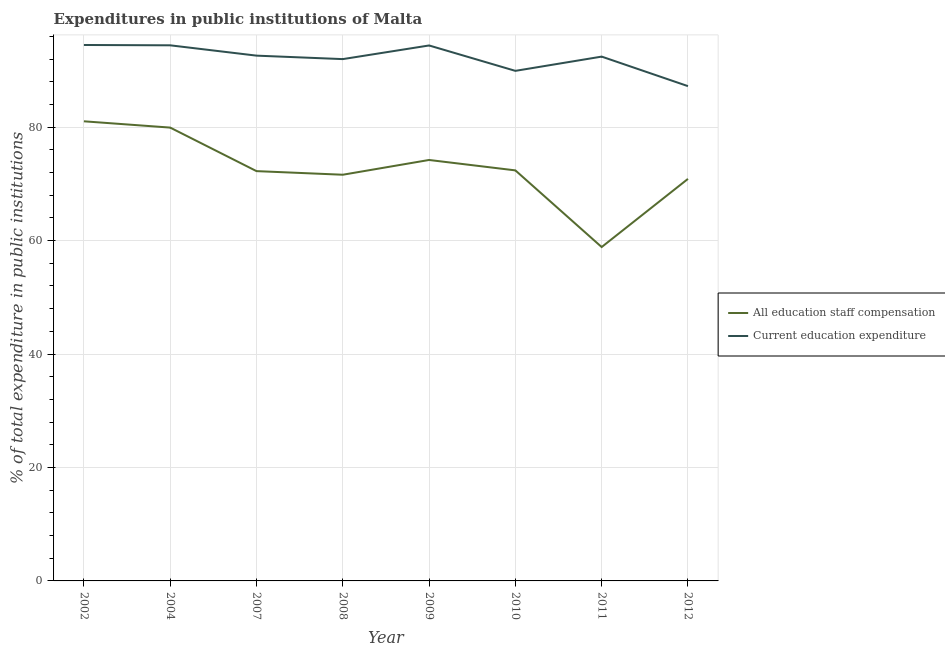How many different coloured lines are there?
Provide a short and direct response. 2. What is the expenditure in staff compensation in 2007?
Offer a terse response. 72.24. Across all years, what is the maximum expenditure in staff compensation?
Your answer should be compact. 81.02. Across all years, what is the minimum expenditure in staff compensation?
Make the answer very short. 58.86. In which year was the expenditure in staff compensation minimum?
Offer a very short reply. 2011. What is the total expenditure in education in the graph?
Give a very brief answer. 737.44. What is the difference between the expenditure in staff compensation in 2010 and that in 2011?
Provide a succinct answer. 13.51. What is the difference between the expenditure in staff compensation in 2011 and the expenditure in education in 2009?
Offer a terse response. -35.53. What is the average expenditure in education per year?
Offer a very short reply. 92.18. In the year 2004, what is the difference between the expenditure in staff compensation and expenditure in education?
Keep it short and to the point. -14.51. In how many years, is the expenditure in staff compensation greater than 16 %?
Provide a succinct answer. 8. What is the ratio of the expenditure in education in 2002 to that in 2007?
Make the answer very short. 1.02. What is the difference between the highest and the second highest expenditure in education?
Make the answer very short. 0.06. What is the difference between the highest and the lowest expenditure in education?
Your answer should be very brief. 7.25. How many lines are there?
Give a very brief answer. 2. How many years are there in the graph?
Your answer should be compact. 8. How many legend labels are there?
Provide a short and direct response. 2. How are the legend labels stacked?
Ensure brevity in your answer.  Vertical. What is the title of the graph?
Give a very brief answer. Expenditures in public institutions of Malta. Does "Public credit registry" appear as one of the legend labels in the graph?
Ensure brevity in your answer.  No. What is the label or title of the X-axis?
Give a very brief answer. Year. What is the label or title of the Y-axis?
Offer a terse response. % of total expenditure in public institutions. What is the % of total expenditure in public institutions of All education staff compensation in 2002?
Offer a very short reply. 81.02. What is the % of total expenditure in public institutions in Current education expenditure in 2002?
Your answer should be very brief. 94.48. What is the % of total expenditure in public institutions of All education staff compensation in 2004?
Keep it short and to the point. 79.91. What is the % of total expenditure in public institutions of Current education expenditure in 2004?
Give a very brief answer. 94.42. What is the % of total expenditure in public institutions in All education staff compensation in 2007?
Provide a succinct answer. 72.24. What is the % of total expenditure in public institutions in Current education expenditure in 2007?
Your answer should be very brief. 92.6. What is the % of total expenditure in public institutions in All education staff compensation in 2008?
Ensure brevity in your answer.  71.6. What is the % of total expenditure in public institutions of Current education expenditure in 2008?
Ensure brevity in your answer.  91.99. What is the % of total expenditure in public institutions of All education staff compensation in 2009?
Make the answer very short. 74.21. What is the % of total expenditure in public institutions of Current education expenditure in 2009?
Provide a succinct answer. 94.39. What is the % of total expenditure in public institutions of All education staff compensation in 2010?
Make the answer very short. 72.37. What is the % of total expenditure in public institutions of Current education expenditure in 2010?
Your response must be concise. 89.92. What is the % of total expenditure in public institutions in All education staff compensation in 2011?
Your answer should be very brief. 58.86. What is the % of total expenditure in public institutions in Current education expenditure in 2011?
Make the answer very short. 92.43. What is the % of total expenditure in public institutions of All education staff compensation in 2012?
Ensure brevity in your answer.  70.87. What is the % of total expenditure in public institutions of Current education expenditure in 2012?
Provide a succinct answer. 87.22. Across all years, what is the maximum % of total expenditure in public institutions in All education staff compensation?
Ensure brevity in your answer.  81.02. Across all years, what is the maximum % of total expenditure in public institutions in Current education expenditure?
Make the answer very short. 94.48. Across all years, what is the minimum % of total expenditure in public institutions of All education staff compensation?
Give a very brief answer. 58.86. Across all years, what is the minimum % of total expenditure in public institutions of Current education expenditure?
Give a very brief answer. 87.22. What is the total % of total expenditure in public institutions in All education staff compensation in the graph?
Provide a short and direct response. 581.08. What is the total % of total expenditure in public institutions of Current education expenditure in the graph?
Your answer should be very brief. 737.44. What is the difference between the % of total expenditure in public institutions of All education staff compensation in 2002 and that in 2004?
Offer a very short reply. 1.11. What is the difference between the % of total expenditure in public institutions of Current education expenditure in 2002 and that in 2004?
Provide a succinct answer. 0.06. What is the difference between the % of total expenditure in public institutions in All education staff compensation in 2002 and that in 2007?
Keep it short and to the point. 8.78. What is the difference between the % of total expenditure in public institutions in Current education expenditure in 2002 and that in 2007?
Keep it short and to the point. 1.88. What is the difference between the % of total expenditure in public institutions of All education staff compensation in 2002 and that in 2008?
Provide a short and direct response. 9.42. What is the difference between the % of total expenditure in public institutions in Current education expenditure in 2002 and that in 2008?
Your response must be concise. 2.49. What is the difference between the % of total expenditure in public institutions of All education staff compensation in 2002 and that in 2009?
Make the answer very short. 6.82. What is the difference between the % of total expenditure in public institutions in Current education expenditure in 2002 and that in 2009?
Provide a short and direct response. 0.09. What is the difference between the % of total expenditure in public institutions of All education staff compensation in 2002 and that in 2010?
Your response must be concise. 8.65. What is the difference between the % of total expenditure in public institutions of Current education expenditure in 2002 and that in 2010?
Keep it short and to the point. 4.56. What is the difference between the % of total expenditure in public institutions of All education staff compensation in 2002 and that in 2011?
Give a very brief answer. 22.17. What is the difference between the % of total expenditure in public institutions of Current education expenditure in 2002 and that in 2011?
Your answer should be compact. 2.05. What is the difference between the % of total expenditure in public institutions in All education staff compensation in 2002 and that in 2012?
Make the answer very short. 10.15. What is the difference between the % of total expenditure in public institutions in Current education expenditure in 2002 and that in 2012?
Make the answer very short. 7.25. What is the difference between the % of total expenditure in public institutions of All education staff compensation in 2004 and that in 2007?
Your response must be concise. 7.67. What is the difference between the % of total expenditure in public institutions in Current education expenditure in 2004 and that in 2007?
Provide a succinct answer. 1.82. What is the difference between the % of total expenditure in public institutions of All education staff compensation in 2004 and that in 2008?
Give a very brief answer. 8.31. What is the difference between the % of total expenditure in public institutions of Current education expenditure in 2004 and that in 2008?
Keep it short and to the point. 2.43. What is the difference between the % of total expenditure in public institutions of All education staff compensation in 2004 and that in 2009?
Your answer should be very brief. 5.71. What is the difference between the % of total expenditure in public institutions of Current education expenditure in 2004 and that in 2009?
Offer a very short reply. 0.03. What is the difference between the % of total expenditure in public institutions of All education staff compensation in 2004 and that in 2010?
Your response must be concise. 7.54. What is the difference between the % of total expenditure in public institutions in Current education expenditure in 2004 and that in 2010?
Keep it short and to the point. 4.5. What is the difference between the % of total expenditure in public institutions in All education staff compensation in 2004 and that in 2011?
Give a very brief answer. 21.06. What is the difference between the % of total expenditure in public institutions of Current education expenditure in 2004 and that in 2011?
Your answer should be very brief. 1.99. What is the difference between the % of total expenditure in public institutions of All education staff compensation in 2004 and that in 2012?
Offer a very short reply. 9.04. What is the difference between the % of total expenditure in public institutions in Current education expenditure in 2004 and that in 2012?
Offer a very short reply. 7.19. What is the difference between the % of total expenditure in public institutions of All education staff compensation in 2007 and that in 2008?
Offer a very short reply. 0.64. What is the difference between the % of total expenditure in public institutions of Current education expenditure in 2007 and that in 2008?
Keep it short and to the point. 0.61. What is the difference between the % of total expenditure in public institutions in All education staff compensation in 2007 and that in 2009?
Your response must be concise. -1.97. What is the difference between the % of total expenditure in public institutions in Current education expenditure in 2007 and that in 2009?
Make the answer very short. -1.79. What is the difference between the % of total expenditure in public institutions of All education staff compensation in 2007 and that in 2010?
Your response must be concise. -0.13. What is the difference between the % of total expenditure in public institutions in Current education expenditure in 2007 and that in 2010?
Offer a very short reply. 2.68. What is the difference between the % of total expenditure in public institutions in All education staff compensation in 2007 and that in 2011?
Offer a terse response. 13.38. What is the difference between the % of total expenditure in public institutions of Current education expenditure in 2007 and that in 2011?
Keep it short and to the point. 0.17. What is the difference between the % of total expenditure in public institutions in All education staff compensation in 2007 and that in 2012?
Your answer should be compact. 1.37. What is the difference between the % of total expenditure in public institutions of Current education expenditure in 2007 and that in 2012?
Offer a very short reply. 5.38. What is the difference between the % of total expenditure in public institutions in All education staff compensation in 2008 and that in 2009?
Keep it short and to the point. -2.6. What is the difference between the % of total expenditure in public institutions in Current education expenditure in 2008 and that in 2009?
Provide a short and direct response. -2.41. What is the difference between the % of total expenditure in public institutions in All education staff compensation in 2008 and that in 2010?
Make the answer very short. -0.77. What is the difference between the % of total expenditure in public institutions of Current education expenditure in 2008 and that in 2010?
Give a very brief answer. 2.07. What is the difference between the % of total expenditure in public institutions in All education staff compensation in 2008 and that in 2011?
Give a very brief answer. 12.75. What is the difference between the % of total expenditure in public institutions of Current education expenditure in 2008 and that in 2011?
Offer a very short reply. -0.44. What is the difference between the % of total expenditure in public institutions of All education staff compensation in 2008 and that in 2012?
Offer a very short reply. 0.73. What is the difference between the % of total expenditure in public institutions of Current education expenditure in 2008 and that in 2012?
Ensure brevity in your answer.  4.76. What is the difference between the % of total expenditure in public institutions in All education staff compensation in 2009 and that in 2010?
Keep it short and to the point. 1.83. What is the difference between the % of total expenditure in public institutions of Current education expenditure in 2009 and that in 2010?
Your answer should be very brief. 4.48. What is the difference between the % of total expenditure in public institutions of All education staff compensation in 2009 and that in 2011?
Offer a very short reply. 15.35. What is the difference between the % of total expenditure in public institutions in Current education expenditure in 2009 and that in 2011?
Your response must be concise. 1.96. What is the difference between the % of total expenditure in public institutions of All education staff compensation in 2009 and that in 2012?
Your response must be concise. 3.33. What is the difference between the % of total expenditure in public institutions in Current education expenditure in 2009 and that in 2012?
Offer a terse response. 7.17. What is the difference between the % of total expenditure in public institutions of All education staff compensation in 2010 and that in 2011?
Give a very brief answer. 13.51. What is the difference between the % of total expenditure in public institutions in Current education expenditure in 2010 and that in 2011?
Your response must be concise. -2.51. What is the difference between the % of total expenditure in public institutions in All education staff compensation in 2010 and that in 2012?
Offer a very short reply. 1.5. What is the difference between the % of total expenditure in public institutions in Current education expenditure in 2010 and that in 2012?
Offer a terse response. 2.69. What is the difference between the % of total expenditure in public institutions of All education staff compensation in 2011 and that in 2012?
Provide a succinct answer. -12.02. What is the difference between the % of total expenditure in public institutions of Current education expenditure in 2011 and that in 2012?
Your response must be concise. 5.2. What is the difference between the % of total expenditure in public institutions of All education staff compensation in 2002 and the % of total expenditure in public institutions of Current education expenditure in 2004?
Provide a succinct answer. -13.4. What is the difference between the % of total expenditure in public institutions in All education staff compensation in 2002 and the % of total expenditure in public institutions in Current education expenditure in 2007?
Provide a succinct answer. -11.58. What is the difference between the % of total expenditure in public institutions of All education staff compensation in 2002 and the % of total expenditure in public institutions of Current education expenditure in 2008?
Ensure brevity in your answer.  -10.96. What is the difference between the % of total expenditure in public institutions of All education staff compensation in 2002 and the % of total expenditure in public institutions of Current education expenditure in 2009?
Your answer should be very brief. -13.37. What is the difference between the % of total expenditure in public institutions of All education staff compensation in 2002 and the % of total expenditure in public institutions of Current education expenditure in 2010?
Give a very brief answer. -8.89. What is the difference between the % of total expenditure in public institutions of All education staff compensation in 2002 and the % of total expenditure in public institutions of Current education expenditure in 2011?
Make the answer very short. -11.41. What is the difference between the % of total expenditure in public institutions in All education staff compensation in 2002 and the % of total expenditure in public institutions in Current education expenditure in 2012?
Your answer should be very brief. -6.2. What is the difference between the % of total expenditure in public institutions of All education staff compensation in 2004 and the % of total expenditure in public institutions of Current education expenditure in 2007?
Offer a very short reply. -12.69. What is the difference between the % of total expenditure in public institutions in All education staff compensation in 2004 and the % of total expenditure in public institutions in Current education expenditure in 2008?
Provide a succinct answer. -12.07. What is the difference between the % of total expenditure in public institutions in All education staff compensation in 2004 and the % of total expenditure in public institutions in Current education expenditure in 2009?
Keep it short and to the point. -14.48. What is the difference between the % of total expenditure in public institutions in All education staff compensation in 2004 and the % of total expenditure in public institutions in Current education expenditure in 2010?
Your response must be concise. -10. What is the difference between the % of total expenditure in public institutions in All education staff compensation in 2004 and the % of total expenditure in public institutions in Current education expenditure in 2011?
Give a very brief answer. -12.52. What is the difference between the % of total expenditure in public institutions of All education staff compensation in 2004 and the % of total expenditure in public institutions of Current education expenditure in 2012?
Your answer should be very brief. -7.31. What is the difference between the % of total expenditure in public institutions in All education staff compensation in 2007 and the % of total expenditure in public institutions in Current education expenditure in 2008?
Provide a short and direct response. -19.75. What is the difference between the % of total expenditure in public institutions in All education staff compensation in 2007 and the % of total expenditure in public institutions in Current education expenditure in 2009?
Provide a short and direct response. -22.15. What is the difference between the % of total expenditure in public institutions of All education staff compensation in 2007 and the % of total expenditure in public institutions of Current education expenditure in 2010?
Your response must be concise. -17.68. What is the difference between the % of total expenditure in public institutions of All education staff compensation in 2007 and the % of total expenditure in public institutions of Current education expenditure in 2011?
Your answer should be compact. -20.19. What is the difference between the % of total expenditure in public institutions of All education staff compensation in 2007 and the % of total expenditure in public institutions of Current education expenditure in 2012?
Your response must be concise. -14.98. What is the difference between the % of total expenditure in public institutions in All education staff compensation in 2008 and the % of total expenditure in public institutions in Current education expenditure in 2009?
Ensure brevity in your answer.  -22.79. What is the difference between the % of total expenditure in public institutions of All education staff compensation in 2008 and the % of total expenditure in public institutions of Current education expenditure in 2010?
Ensure brevity in your answer.  -18.31. What is the difference between the % of total expenditure in public institutions of All education staff compensation in 2008 and the % of total expenditure in public institutions of Current education expenditure in 2011?
Provide a succinct answer. -20.83. What is the difference between the % of total expenditure in public institutions of All education staff compensation in 2008 and the % of total expenditure in public institutions of Current education expenditure in 2012?
Offer a very short reply. -15.62. What is the difference between the % of total expenditure in public institutions of All education staff compensation in 2009 and the % of total expenditure in public institutions of Current education expenditure in 2010?
Your response must be concise. -15.71. What is the difference between the % of total expenditure in public institutions in All education staff compensation in 2009 and the % of total expenditure in public institutions in Current education expenditure in 2011?
Offer a terse response. -18.22. What is the difference between the % of total expenditure in public institutions in All education staff compensation in 2009 and the % of total expenditure in public institutions in Current education expenditure in 2012?
Provide a succinct answer. -13.02. What is the difference between the % of total expenditure in public institutions in All education staff compensation in 2010 and the % of total expenditure in public institutions in Current education expenditure in 2011?
Provide a succinct answer. -20.06. What is the difference between the % of total expenditure in public institutions in All education staff compensation in 2010 and the % of total expenditure in public institutions in Current education expenditure in 2012?
Offer a very short reply. -14.85. What is the difference between the % of total expenditure in public institutions of All education staff compensation in 2011 and the % of total expenditure in public institutions of Current education expenditure in 2012?
Your answer should be very brief. -28.37. What is the average % of total expenditure in public institutions in All education staff compensation per year?
Your response must be concise. 72.64. What is the average % of total expenditure in public institutions of Current education expenditure per year?
Offer a terse response. 92.18. In the year 2002, what is the difference between the % of total expenditure in public institutions in All education staff compensation and % of total expenditure in public institutions in Current education expenditure?
Offer a very short reply. -13.46. In the year 2004, what is the difference between the % of total expenditure in public institutions of All education staff compensation and % of total expenditure in public institutions of Current education expenditure?
Provide a succinct answer. -14.51. In the year 2007, what is the difference between the % of total expenditure in public institutions in All education staff compensation and % of total expenditure in public institutions in Current education expenditure?
Your answer should be very brief. -20.36. In the year 2008, what is the difference between the % of total expenditure in public institutions of All education staff compensation and % of total expenditure in public institutions of Current education expenditure?
Provide a succinct answer. -20.38. In the year 2009, what is the difference between the % of total expenditure in public institutions of All education staff compensation and % of total expenditure in public institutions of Current education expenditure?
Ensure brevity in your answer.  -20.19. In the year 2010, what is the difference between the % of total expenditure in public institutions in All education staff compensation and % of total expenditure in public institutions in Current education expenditure?
Keep it short and to the point. -17.54. In the year 2011, what is the difference between the % of total expenditure in public institutions of All education staff compensation and % of total expenditure in public institutions of Current education expenditure?
Your response must be concise. -33.57. In the year 2012, what is the difference between the % of total expenditure in public institutions in All education staff compensation and % of total expenditure in public institutions in Current education expenditure?
Offer a terse response. -16.35. What is the ratio of the % of total expenditure in public institutions of All education staff compensation in 2002 to that in 2004?
Provide a succinct answer. 1.01. What is the ratio of the % of total expenditure in public institutions of Current education expenditure in 2002 to that in 2004?
Your response must be concise. 1. What is the ratio of the % of total expenditure in public institutions in All education staff compensation in 2002 to that in 2007?
Give a very brief answer. 1.12. What is the ratio of the % of total expenditure in public institutions of Current education expenditure in 2002 to that in 2007?
Your response must be concise. 1.02. What is the ratio of the % of total expenditure in public institutions of All education staff compensation in 2002 to that in 2008?
Offer a very short reply. 1.13. What is the ratio of the % of total expenditure in public institutions of Current education expenditure in 2002 to that in 2008?
Your answer should be compact. 1.03. What is the ratio of the % of total expenditure in public institutions in All education staff compensation in 2002 to that in 2009?
Give a very brief answer. 1.09. What is the ratio of the % of total expenditure in public institutions of All education staff compensation in 2002 to that in 2010?
Keep it short and to the point. 1.12. What is the ratio of the % of total expenditure in public institutions of Current education expenditure in 2002 to that in 2010?
Offer a very short reply. 1.05. What is the ratio of the % of total expenditure in public institutions in All education staff compensation in 2002 to that in 2011?
Keep it short and to the point. 1.38. What is the ratio of the % of total expenditure in public institutions of Current education expenditure in 2002 to that in 2011?
Make the answer very short. 1.02. What is the ratio of the % of total expenditure in public institutions in All education staff compensation in 2002 to that in 2012?
Your answer should be very brief. 1.14. What is the ratio of the % of total expenditure in public institutions in Current education expenditure in 2002 to that in 2012?
Your answer should be compact. 1.08. What is the ratio of the % of total expenditure in public institutions in All education staff compensation in 2004 to that in 2007?
Provide a succinct answer. 1.11. What is the ratio of the % of total expenditure in public institutions of Current education expenditure in 2004 to that in 2007?
Your answer should be very brief. 1.02. What is the ratio of the % of total expenditure in public institutions of All education staff compensation in 2004 to that in 2008?
Provide a succinct answer. 1.12. What is the ratio of the % of total expenditure in public institutions in Current education expenditure in 2004 to that in 2008?
Give a very brief answer. 1.03. What is the ratio of the % of total expenditure in public institutions of Current education expenditure in 2004 to that in 2009?
Make the answer very short. 1. What is the ratio of the % of total expenditure in public institutions in All education staff compensation in 2004 to that in 2010?
Keep it short and to the point. 1.1. What is the ratio of the % of total expenditure in public institutions in Current education expenditure in 2004 to that in 2010?
Your answer should be very brief. 1.05. What is the ratio of the % of total expenditure in public institutions in All education staff compensation in 2004 to that in 2011?
Provide a succinct answer. 1.36. What is the ratio of the % of total expenditure in public institutions of Current education expenditure in 2004 to that in 2011?
Keep it short and to the point. 1.02. What is the ratio of the % of total expenditure in public institutions in All education staff compensation in 2004 to that in 2012?
Ensure brevity in your answer.  1.13. What is the ratio of the % of total expenditure in public institutions in Current education expenditure in 2004 to that in 2012?
Provide a short and direct response. 1.08. What is the ratio of the % of total expenditure in public institutions in All education staff compensation in 2007 to that in 2008?
Your answer should be compact. 1.01. What is the ratio of the % of total expenditure in public institutions in Current education expenditure in 2007 to that in 2008?
Your response must be concise. 1.01. What is the ratio of the % of total expenditure in public institutions in All education staff compensation in 2007 to that in 2009?
Make the answer very short. 0.97. What is the ratio of the % of total expenditure in public institutions in Current education expenditure in 2007 to that in 2009?
Give a very brief answer. 0.98. What is the ratio of the % of total expenditure in public institutions in All education staff compensation in 2007 to that in 2010?
Make the answer very short. 1. What is the ratio of the % of total expenditure in public institutions of Current education expenditure in 2007 to that in 2010?
Provide a succinct answer. 1.03. What is the ratio of the % of total expenditure in public institutions in All education staff compensation in 2007 to that in 2011?
Provide a succinct answer. 1.23. What is the ratio of the % of total expenditure in public institutions of Current education expenditure in 2007 to that in 2011?
Ensure brevity in your answer.  1. What is the ratio of the % of total expenditure in public institutions of All education staff compensation in 2007 to that in 2012?
Make the answer very short. 1.02. What is the ratio of the % of total expenditure in public institutions of Current education expenditure in 2007 to that in 2012?
Make the answer very short. 1.06. What is the ratio of the % of total expenditure in public institutions of All education staff compensation in 2008 to that in 2009?
Your response must be concise. 0.96. What is the ratio of the % of total expenditure in public institutions in Current education expenditure in 2008 to that in 2009?
Ensure brevity in your answer.  0.97. What is the ratio of the % of total expenditure in public institutions in Current education expenditure in 2008 to that in 2010?
Offer a terse response. 1.02. What is the ratio of the % of total expenditure in public institutions of All education staff compensation in 2008 to that in 2011?
Your answer should be compact. 1.22. What is the ratio of the % of total expenditure in public institutions of Current education expenditure in 2008 to that in 2011?
Make the answer very short. 1. What is the ratio of the % of total expenditure in public institutions of All education staff compensation in 2008 to that in 2012?
Your response must be concise. 1.01. What is the ratio of the % of total expenditure in public institutions of Current education expenditure in 2008 to that in 2012?
Give a very brief answer. 1.05. What is the ratio of the % of total expenditure in public institutions in All education staff compensation in 2009 to that in 2010?
Your response must be concise. 1.03. What is the ratio of the % of total expenditure in public institutions of Current education expenditure in 2009 to that in 2010?
Offer a very short reply. 1.05. What is the ratio of the % of total expenditure in public institutions of All education staff compensation in 2009 to that in 2011?
Give a very brief answer. 1.26. What is the ratio of the % of total expenditure in public institutions of Current education expenditure in 2009 to that in 2011?
Give a very brief answer. 1.02. What is the ratio of the % of total expenditure in public institutions in All education staff compensation in 2009 to that in 2012?
Offer a very short reply. 1.05. What is the ratio of the % of total expenditure in public institutions of Current education expenditure in 2009 to that in 2012?
Make the answer very short. 1.08. What is the ratio of the % of total expenditure in public institutions of All education staff compensation in 2010 to that in 2011?
Offer a very short reply. 1.23. What is the ratio of the % of total expenditure in public institutions in Current education expenditure in 2010 to that in 2011?
Your answer should be compact. 0.97. What is the ratio of the % of total expenditure in public institutions of All education staff compensation in 2010 to that in 2012?
Make the answer very short. 1.02. What is the ratio of the % of total expenditure in public institutions in Current education expenditure in 2010 to that in 2012?
Your response must be concise. 1.03. What is the ratio of the % of total expenditure in public institutions of All education staff compensation in 2011 to that in 2012?
Your response must be concise. 0.83. What is the ratio of the % of total expenditure in public institutions of Current education expenditure in 2011 to that in 2012?
Make the answer very short. 1.06. What is the difference between the highest and the second highest % of total expenditure in public institutions of All education staff compensation?
Offer a terse response. 1.11. What is the difference between the highest and the second highest % of total expenditure in public institutions in Current education expenditure?
Your response must be concise. 0.06. What is the difference between the highest and the lowest % of total expenditure in public institutions of All education staff compensation?
Your response must be concise. 22.17. What is the difference between the highest and the lowest % of total expenditure in public institutions of Current education expenditure?
Ensure brevity in your answer.  7.25. 